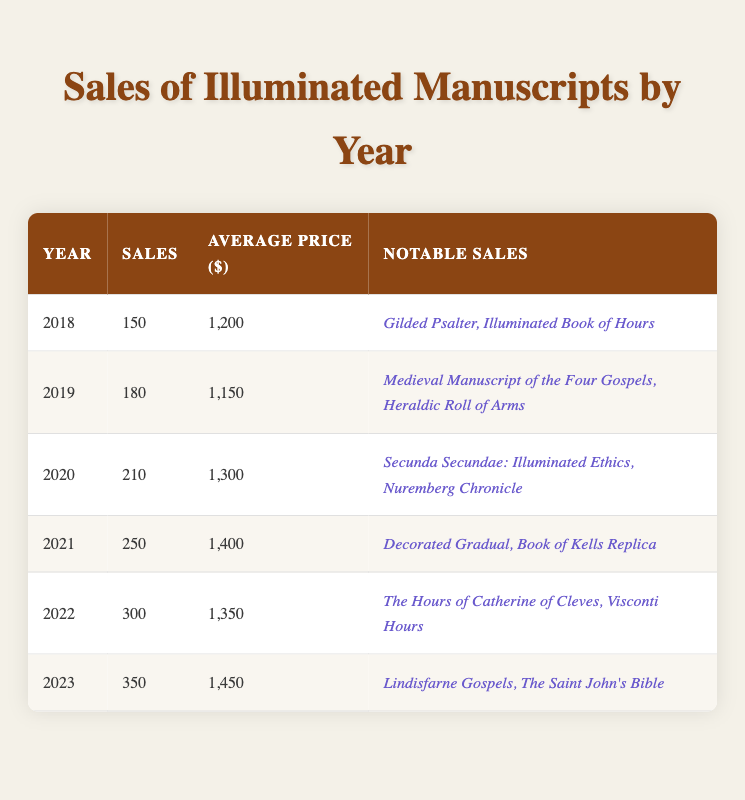What was the total number of illuminated manuscripts sold in 2021? In 2021, the sales of illuminated manuscripts were 250. Therefore, the total number sold in that year is 250.
Answer: 250 Which year had the highest average price of illuminated manuscripts? The average prices for each year are 1200 (2018), 1150 (2019), 1300 (2020), 1400 (2021), 1350 (2022), and 1450 (2023). Comparing these values, 2023 has the highest average price at 1450.
Answer: 2023 How many more illuminated manuscripts were sold in 2023 compared to 2018? In 2023, 350 manuscripts were sold, and in 2018, 150 were sold. The difference is 350 - 150 = 200.
Answer: 200 What was the average number of illuminated manuscripts sold from 2018 to 2022? The sales from 2018 to 2022 are 150, 180, 210, 250, and 300. Summing these gives 150 + 180 + 210 + 250 + 300 = 1090. Since there are 5 years, the average is 1090 / 5 = 218.
Answer: 218 Did the average price of illuminated manuscripts increase from 2020 to 2022? The average prices are 1300 (2020) and 1350 (2022). Comparing these prices, 1350 is greater than 1300, indicating an increase.
Answer: Yes What was the percentage increase in sales from 2021 to 2023? The sales in 2021 were 250 and in 2023 were 350. The increase can be calculated as (350 - 250) / 250 * 100 = 40%.
Answer: 40% How many notable sales were listed for the year 2020? The year 2020 had two notable sales: "Secunda Secundae: Illuminated Ethics" and "Nuremberg Chronicle." Therefore, the total number of notable sales is 2.
Answer: 2 What is the total average price of illuminated manuscripts from 2019 to 2021? The average prices for those years are 1150 (2019), 1300 (2020), and 1400 (2021). Summing these gives 1150 + 1300 + 1400 = 3850. To find the average over the three years, divide by 3: 3850 / 3 = approximately 1283.33.
Answer: 1283.33 In which year was the "Lindisfarne Gospels" sold? The "Lindisfarne Gospels" was sold in 2023, as listed under that year's notable sales.
Answer: 2023 What was the trend in sales from 2018 to 2023? The sales figures from 2018 (150) to 2023 (350) show a consistent increase each year: 150, 180, 210, 250, 300, 350. This indicates an upward trend in sales over the years.
Answer: Upward trend 